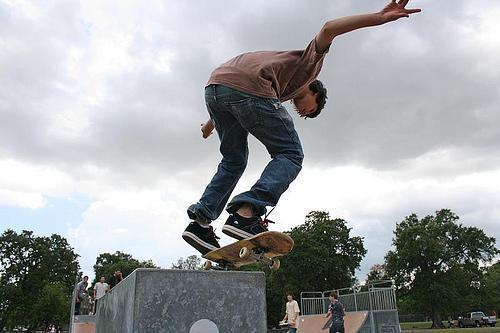How many boys are in the picture?
Give a very brief answer. 6. 